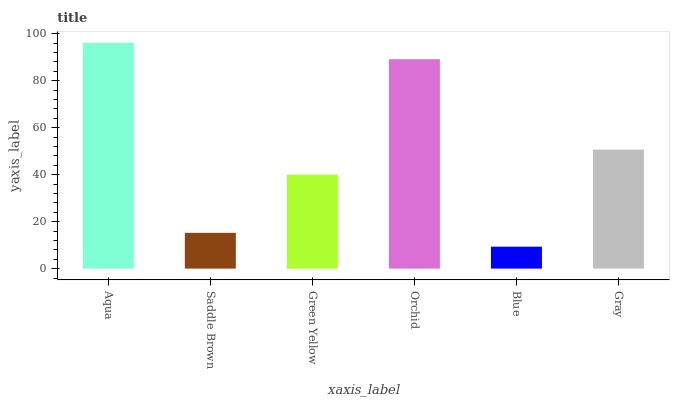Is Saddle Brown the minimum?
Answer yes or no. No. Is Saddle Brown the maximum?
Answer yes or no. No. Is Aqua greater than Saddle Brown?
Answer yes or no. Yes. Is Saddle Brown less than Aqua?
Answer yes or no. Yes. Is Saddle Brown greater than Aqua?
Answer yes or no. No. Is Aqua less than Saddle Brown?
Answer yes or no. No. Is Gray the high median?
Answer yes or no. Yes. Is Green Yellow the low median?
Answer yes or no. Yes. Is Blue the high median?
Answer yes or no. No. Is Saddle Brown the low median?
Answer yes or no. No. 